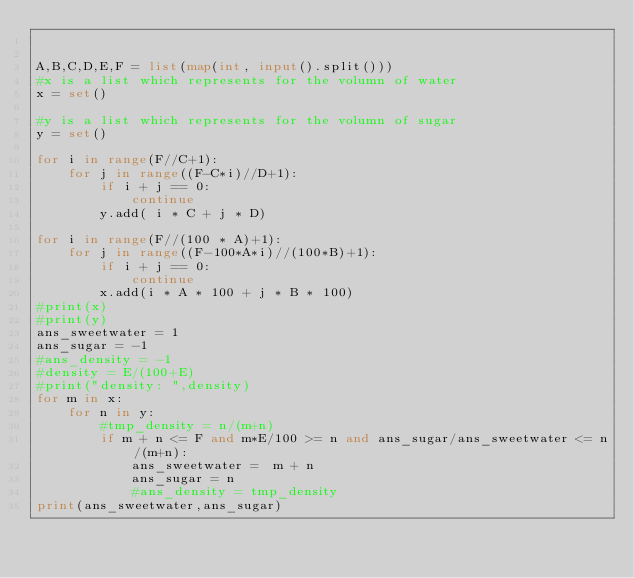Convert code to text. <code><loc_0><loc_0><loc_500><loc_500><_Python_>

A,B,C,D,E,F = list(map(int, input().split()))
#x is a list which represents for the volumn of water
x = set()

#y is a list which represents for the volumn of sugar
y = set()

for i in range(F//C+1):
    for j in range((F-C*i)//D+1):
        if i + j == 0:
            continue
        y.add( i * C + j * D)

for i in range(F//(100 * A)+1):
    for j in range((F-100*A*i)//(100*B)+1):
        if i + j == 0:
            continue
        x.add(i * A * 100 + j * B * 100)
#print(x)
#print(y)
ans_sweetwater = 1
ans_sugar = -1
#ans_density = -1
#density = E/(100+E)
#print("density: ",density)
for m in x:
    for n in y:
        #tmp_density = n/(m+n)
        if m + n <= F and m*E/100 >= n and ans_sugar/ans_sweetwater <= n/(m+n):
            ans_sweetwater =  m + n
            ans_sugar = n
            #ans_density = tmp_density
print(ans_sweetwater,ans_sugar)
</code> 